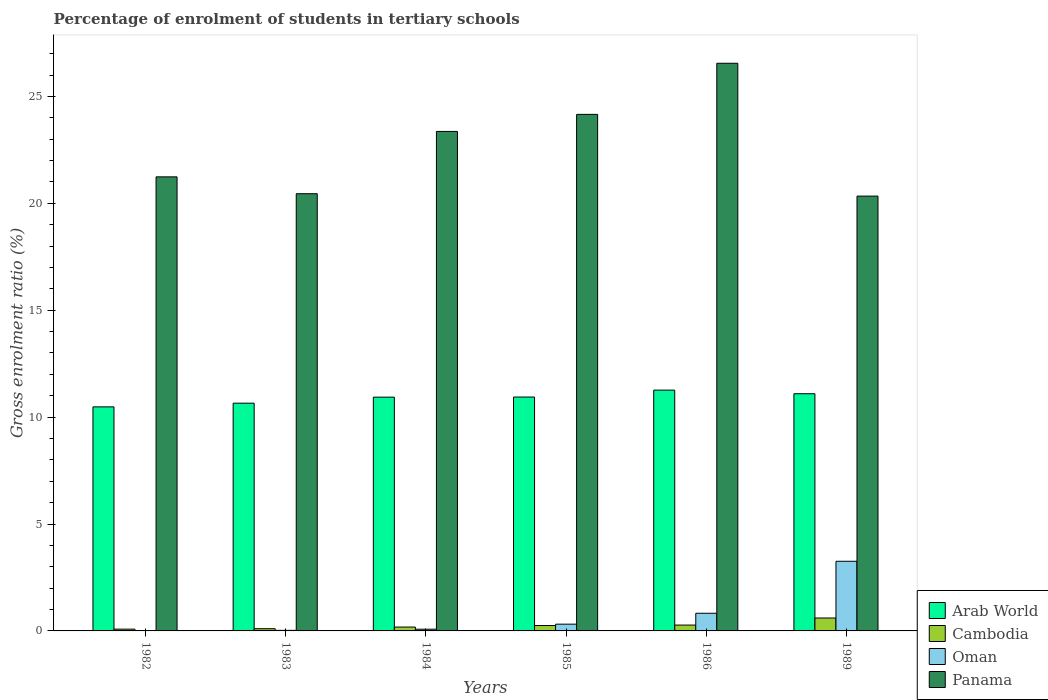How many different coloured bars are there?
Give a very brief answer. 4. Are the number of bars per tick equal to the number of legend labels?
Keep it short and to the point. Yes. Are the number of bars on each tick of the X-axis equal?
Your response must be concise. Yes. How many bars are there on the 2nd tick from the right?
Your response must be concise. 4. What is the label of the 4th group of bars from the left?
Offer a very short reply. 1985. What is the percentage of students enrolled in tertiary schools in Oman in 1986?
Make the answer very short. 0.83. Across all years, what is the maximum percentage of students enrolled in tertiary schools in Oman?
Your answer should be very brief. 3.26. Across all years, what is the minimum percentage of students enrolled in tertiary schools in Panama?
Make the answer very short. 20.34. In which year was the percentage of students enrolled in tertiary schools in Panama minimum?
Give a very brief answer. 1989. What is the total percentage of students enrolled in tertiary schools in Arab World in the graph?
Offer a very short reply. 65.36. What is the difference between the percentage of students enrolled in tertiary schools in Arab World in 1982 and that in 1986?
Offer a terse response. -0.78. What is the difference between the percentage of students enrolled in tertiary schools in Oman in 1983 and the percentage of students enrolled in tertiary schools in Cambodia in 1985?
Give a very brief answer. -0.23. What is the average percentage of students enrolled in tertiary schools in Arab World per year?
Offer a very short reply. 10.89. In the year 1985, what is the difference between the percentage of students enrolled in tertiary schools in Oman and percentage of students enrolled in tertiary schools in Cambodia?
Make the answer very short. 0.06. What is the ratio of the percentage of students enrolled in tertiary schools in Oman in 1983 to that in 1986?
Provide a short and direct response. 0.03. Is the percentage of students enrolled in tertiary schools in Oman in 1984 less than that in 1986?
Provide a succinct answer. Yes. Is the difference between the percentage of students enrolled in tertiary schools in Oman in 1982 and 1985 greater than the difference between the percentage of students enrolled in tertiary schools in Cambodia in 1982 and 1985?
Your response must be concise. No. What is the difference between the highest and the second highest percentage of students enrolled in tertiary schools in Panama?
Your response must be concise. 2.39. What is the difference between the highest and the lowest percentage of students enrolled in tertiary schools in Arab World?
Give a very brief answer. 0.78. Is the sum of the percentage of students enrolled in tertiary schools in Cambodia in 1986 and 1989 greater than the maximum percentage of students enrolled in tertiary schools in Panama across all years?
Your response must be concise. No. Is it the case that in every year, the sum of the percentage of students enrolled in tertiary schools in Cambodia and percentage of students enrolled in tertiary schools in Arab World is greater than the sum of percentage of students enrolled in tertiary schools in Panama and percentage of students enrolled in tertiary schools in Oman?
Keep it short and to the point. Yes. What does the 1st bar from the left in 1986 represents?
Offer a very short reply. Arab World. What does the 4th bar from the right in 1983 represents?
Provide a succinct answer. Arab World. How many bars are there?
Your answer should be very brief. 24. What is the difference between two consecutive major ticks on the Y-axis?
Provide a short and direct response. 5. Does the graph contain grids?
Keep it short and to the point. No. Where does the legend appear in the graph?
Give a very brief answer. Bottom right. What is the title of the graph?
Ensure brevity in your answer.  Percentage of enrolment of students in tertiary schools. What is the label or title of the X-axis?
Keep it short and to the point. Years. What is the Gross enrolment ratio (%) of Arab World in 1982?
Make the answer very short. 10.48. What is the Gross enrolment ratio (%) in Cambodia in 1982?
Give a very brief answer. 0.08. What is the Gross enrolment ratio (%) of Oman in 1982?
Offer a very short reply. 0.01. What is the Gross enrolment ratio (%) of Panama in 1982?
Offer a very short reply. 21.24. What is the Gross enrolment ratio (%) of Arab World in 1983?
Offer a terse response. 10.65. What is the Gross enrolment ratio (%) in Cambodia in 1983?
Provide a succinct answer. 0.1. What is the Gross enrolment ratio (%) in Oman in 1983?
Your response must be concise. 0.03. What is the Gross enrolment ratio (%) of Panama in 1983?
Your answer should be compact. 20.45. What is the Gross enrolment ratio (%) in Arab World in 1984?
Ensure brevity in your answer.  10.93. What is the Gross enrolment ratio (%) of Cambodia in 1984?
Offer a terse response. 0.18. What is the Gross enrolment ratio (%) in Oman in 1984?
Your response must be concise. 0.08. What is the Gross enrolment ratio (%) of Panama in 1984?
Provide a succinct answer. 23.36. What is the Gross enrolment ratio (%) of Arab World in 1985?
Offer a terse response. 10.94. What is the Gross enrolment ratio (%) of Cambodia in 1985?
Provide a succinct answer. 0.25. What is the Gross enrolment ratio (%) in Oman in 1985?
Make the answer very short. 0.32. What is the Gross enrolment ratio (%) in Panama in 1985?
Your response must be concise. 24.16. What is the Gross enrolment ratio (%) in Arab World in 1986?
Offer a terse response. 11.26. What is the Gross enrolment ratio (%) of Cambodia in 1986?
Your answer should be compact. 0.27. What is the Gross enrolment ratio (%) of Oman in 1986?
Offer a terse response. 0.83. What is the Gross enrolment ratio (%) of Panama in 1986?
Your response must be concise. 26.55. What is the Gross enrolment ratio (%) in Arab World in 1989?
Make the answer very short. 11.09. What is the Gross enrolment ratio (%) of Cambodia in 1989?
Keep it short and to the point. 0.6. What is the Gross enrolment ratio (%) of Oman in 1989?
Give a very brief answer. 3.26. What is the Gross enrolment ratio (%) in Panama in 1989?
Make the answer very short. 20.34. Across all years, what is the maximum Gross enrolment ratio (%) of Arab World?
Provide a short and direct response. 11.26. Across all years, what is the maximum Gross enrolment ratio (%) of Cambodia?
Provide a succinct answer. 0.6. Across all years, what is the maximum Gross enrolment ratio (%) of Oman?
Provide a short and direct response. 3.26. Across all years, what is the maximum Gross enrolment ratio (%) in Panama?
Offer a terse response. 26.55. Across all years, what is the minimum Gross enrolment ratio (%) in Arab World?
Provide a short and direct response. 10.48. Across all years, what is the minimum Gross enrolment ratio (%) of Cambodia?
Offer a very short reply. 0.08. Across all years, what is the minimum Gross enrolment ratio (%) in Oman?
Offer a very short reply. 0.01. Across all years, what is the minimum Gross enrolment ratio (%) in Panama?
Make the answer very short. 20.34. What is the total Gross enrolment ratio (%) of Arab World in the graph?
Your answer should be compact. 65.36. What is the total Gross enrolment ratio (%) in Cambodia in the graph?
Keep it short and to the point. 1.5. What is the total Gross enrolment ratio (%) of Oman in the graph?
Offer a very short reply. 4.52. What is the total Gross enrolment ratio (%) of Panama in the graph?
Your response must be concise. 136.09. What is the difference between the Gross enrolment ratio (%) in Arab World in 1982 and that in 1983?
Make the answer very short. -0.17. What is the difference between the Gross enrolment ratio (%) in Cambodia in 1982 and that in 1983?
Provide a succinct answer. -0.02. What is the difference between the Gross enrolment ratio (%) of Oman in 1982 and that in 1983?
Make the answer very short. -0.01. What is the difference between the Gross enrolment ratio (%) of Panama in 1982 and that in 1983?
Keep it short and to the point. 0.79. What is the difference between the Gross enrolment ratio (%) of Arab World in 1982 and that in 1984?
Give a very brief answer. -0.45. What is the difference between the Gross enrolment ratio (%) of Cambodia in 1982 and that in 1984?
Offer a very short reply. -0.1. What is the difference between the Gross enrolment ratio (%) of Oman in 1982 and that in 1984?
Your answer should be very brief. -0.07. What is the difference between the Gross enrolment ratio (%) of Panama in 1982 and that in 1984?
Offer a very short reply. -2.12. What is the difference between the Gross enrolment ratio (%) of Arab World in 1982 and that in 1985?
Keep it short and to the point. -0.46. What is the difference between the Gross enrolment ratio (%) of Cambodia in 1982 and that in 1985?
Your answer should be compact. -0.17. What is the difference between the Gross enrolment ratio (%) in Oman in 1982 and that in 1985?
Provide a short and direct response. -0.3. What is the difference between the Gross enrolment ratio (%) in Panama in 1982 and that in 1985?
Make the answer very short. -2.92. What is the difference between the Gross enrolment ratio (%) of Arab World in 1982 and that in 1986?
Make the answer very short. -0.78. What is the difference between the Gross enrolment ratio (%) in Cambodia in 1982 and that in 1986?
Give a very brief answer. -0.19. What is the difference between the Gross enrolment ratio (%) of Oman in 1982 and that in 1986?
Make the answer very short. -0.81. What is the difference between the Gross enrolment ratio (%) of Panama in 1982 and that in 1986?
Make the answer very short. -5.31. What is the difference between the Gross enrolment ratio (%) in Arab World in 1982 and that in 1989?
Keep it short and to the point. -0.61. What is the difference between the Gross enrolment ratio (%) of Cambodia in 1982 and that in 1989?
Offer a terse response. -0.52. What is the difference between the Gross enrolment ratio (%) of Oman in 1982 and that in 1989?
Your answer should be compact. -3.24. What is the difference between the Gross enrolment ratio (%) in Panama in 1982 and that in 1989?
Your answer should be compact. 0.9. What is the difference between the Gross enrolment ratio (%) of Arab World in 1983 and that in 1984?
Your answer should be very brief. -0.28. What is the difference between the Gross enrolment ratio (%) in Cambodia in 1983 and that in 1984?
Your response must be concise. -0.08. What is the difference between the Gross enrolment ratio (%) of Oman in 1983 and that in 1984?
Give a very brief answer. -0.05. What is the difference between the Gross enrolment ratio (%) in Panama in 1983 and that in 1984?
Your answer should be compact. -2.91. What is the difference between the Gross enrolment ratio (%) in Arab World in 1983 and that in 1985?
Make the answer very short. -0.29. What is the difference between the Gross enrolment ratio (%) in Cambodia in 1983 and that in 1985?
Offer a very short reply. -0.15. What is the difference between the Gross enrolment ratio (%) of Oman in 1983 and that in 1985?
Offer a very short reply. -0.29. What is the difference between the Gross enrolment ratio (%) of Panama in 1983 and that in 1985?
Provide a succinct answer. -3.71. What is the difference between the Gross enrolment ratio (%) of Arab World in 1983 and that in 1986?
Provide a short and direct response. -0.61. What is the difference between the Gross enrolment ratio (%) in Cambodia in 1983 and that in 1986?
Your response must be concise. -0.17. What is the difference between the Gross enrolment ratio (%) in Oman in 1983 and that in 1986?
Ensure brevity in your answer.  -0.8. What is the difference between the Gross enrolment ratio (%) of Panama in 1983 and that in 1986?
Offer a terse response. -6.1. What is the difference between the Gross enrolment ratio (%) of Arab World in 1983 and that in 1989?
Keep it short and to the point. -0.44. What is the difference between the Gross enrolment ratio (%) in Cambodia in 1983 and that in 1989?
Keep it short and to the point. -0.5. What is the difference between the Gross enrolment ratio (%) in Oman in 1983 and that in 1989?
Your answer should be compact. -3.23. What is the difference between the Gross enrolment ratio (%) of Panama in 1983 and that in 1989?
Make the answer very short. 0.11. What is the difference between the Gross enrolment ratio (%) in Arab World in 1984 and that in 1985?
Make the answer very short. -0. What is the difference between the Gross enrolment ratio (%) in Cambodia in 1984 and that in 1985?
Your answer should be very brief. -0.07. What is the difference between the Gross enrolment ratio (%) in Oman in 1984 and that in 1985?
Make the answer very short. -0.24. What is the difference between the Gross enrolment ratio (%) of Panama in 1984 and that in 1985?
Provide a short and direct response. -0.8. What is the difference between the Gross enrolment ratio (%) in Arab World in 1984 and that in 1986?
Ensure brevity in your answer.  -0.33. What is the difference between the Gross enrolment ratio (%) of Cambodia in 1984 and that in 1986?
Provide a short and direct response. -0.09. What is the difference between the Gross enrolment ratio (%) in Oman in 1984 and that in 1986?
Give a very brief answer. -0.75. What is the difference between the Gross enrolment ratio (%) in Panama in 1984 and that in 1986?
Offer a terse response. -3.19. What is the difference between the Gross enrolment ratio (%) in Arab World in 1984 and that in 1989?
Your answer should be compact. -0.16. What is the difference between the Gross enrolment ratio (%) of Cambodia in 1984 and that in 1989?
Your answer should be compact. -0.42. What is the difference between the Gross enrolment ratio (%) in Oman in 1984 and that in 1989?
Your answer should be compact. -3.18. What is the difference between the Gross enrolment ratio (%) of Panama in 1984 and that in 1989?
Give a very brief answer. 3.03. What is the difference between the Gross enrolment ratio (%) in Arab World in 1985 and that in 1986?
Your answer should be compact. -0.32. What is the difference between the Gross enrolment ratio (%) in Cambodia in 1985 and that in 1986?
Provide a short and direct response. -0.02. What is the difference between the Gross enrolment ratio (%) in Oman in 1985 and that in 1986?
Keep it short and to the point. -0.51. What is the difference between the Gross enrolment ratio (%) of Panama in 1985 and that in 1986?
Give a very brief answer. -2.39. What is the difference between the Gross enrolment ratio (%) in Arab World in 1985 and that in 1989?
Make the answer very short. -0.16. What is the difference between the Gross enrolment ratio (%) of Cambodia in 1985 and that in 1989?
Keep it short and to the point. -0.35. What is the difference between the Gross enrolment ratio (%) of Oman in 1985 and that in 1989?
Offer a terse response. -2.94. What is the difference between the Gross enrolment ratio (%) of Panama in 1985 and that in 1989?
Offer a terse response. 3.82. What is the difference between the Gross enrolment ratio (%) in Arab World in 1986 and that in 1989?
Make the answer very short. 0.17. What is the difference between the Gross enrolment ratio (%) in Cambodia in 1986 and that in 1989?
Give a very brief answer. -0.33. What is the difference between the Gross enrolment ratio (%) of Oman in 1986 and that in 1989?
Give a very brief answer. -2.43. What is the difference between the Gross enrolment ratio (%) of Panama in 1986 and that in 1989?
Your response must be concise. 6.21. What is the difference between the Gross enrolment ratio (%) of Arab World in 1982 and the Gross enrolment ratio (%) of Cambodia in 1983?
Keep it short and to the point. 10.38. What is the difference between the Gross enrolment ratio (%) of Arab World in 1982 and the Gross enrolment ratio (%) of Oman in 1983?
Provide a short and direct response. 10.45. What is the difference between the Gross enrolment ratio (%) in Arab World in 1982 and the Gross enrolment ratio (%) in Panama in 1983?
Offer a very short reply. -9.97. What is the difference between the Gross enrolment ratio (%) of Cambodia in 1982 and the Gross enrolment ratio (%) of Oman in 1983?
Give a very brief answer. 0.06. What is the difference between the Gross enrolment ratio (%) of Cambodia in 1982 and the Gross enrolment ratio (%) of Panama in 1983?
Offer a terse response. -20.37. What is the difference between the Gross enrolment ratio (%) in Oman in 1982 and the Gross enrolment ratio (%) in Panama in 1983?
Offer a terse response. -20.44. What is the difference between the Gross enrolment ratio (%) in Arab World in 1982 and the Gross enrolment ratio (%) in Cambodia in 1984?
Give a very brief answer. 10.3. What is the difference between the Gross enrolment ratio (%) in Arab World in 1982 and the Gross enrolment ratio (%) in Oman in 1984?
Provide a short and direct response. 10.4. What is the difference between the Gross enrolment ratio (%) of Arab World in 1982 and the Gross enrolment ratio (%) of Panama in 1984?
Your answer should be very brief. -12.88. What is the difference between the Gross enrolment ratio (%) in Cambodia in 1982 and the Gross enrolment ratio (%) in Oman in 1984?
Your answer should be compact. 0. What is the difference between the Gross enrolment ratio (%) of Cambodia in 1982 and the Gross enrolment ratio (%) of Panama in 1984?
Offer a very short reply. -23.28. What is the difference between the Gross enrolment ratio (%) of Oman in 1982 and the Gross enrolment ratio (%) of Panama in 1984?
Offer a very short reply. -23.35. What is the difference between the Gross enrolment ratio (%) in Arab World in 1982 and the Gross enrolment ratio (%) in Cambodia in 1985?
Offer a very short reply. 10.23. What is the difference between the Gross enrolment ratio (%) of Arab World in 1982 and the Gross enrolment ratio (%) of Oman in 1985?
Your answer should be very brief. 10.16. What is the difference between the Gross enrolment ratio (%) in Arab World in 1982 and the Gross enrolment ratio (%) in Panama in 1985?
Offer a terse response. -13.68. What is the difference between the Gross enrolment ratio (%) in Cambodia in 1982 and the Gross enrolment ratio (%) in Oman in 1985?
Provide a succinct answer. -0.23. What is the difference between the Gross enrolment ratio (%) of Cambodia in 1982 and the Gross enrolment ratio (%) of Panama in 1985?
Give a very brief answer. -24.08. What is the difference between the Gross enrolment ratio (%) in Oman in 1982 and the Gross enrolment ratio (%) in Panama in 1985?
Keep it short and to the point. -24.15. What is the difference between the Gross enrolment ratio (%) in Arab World in 1982 and the Gross enrolment ratio (%) in Cambodia in 1986?
Offer a terse response. 10.21. What is the difference between the Gross enrolment ratio (%) of Arab World in 1982 and the Gross enrolment ratio (%) of Oman in 1986?
Ensure brevity in your answer.  9.65. What is the difference between the Gross enrolment ratio (%) of Arab World in 1982 and the Gross enrolment ratio (%) of Panama in 1986?
Offer a very short reply. -16.07. What is the difference between the Gross enrolment ratio (%) of Cambodia in 1982 and the Gross enrolment ratio (%) of Oman in 1986?
Provide a succinct answer. -0.74. What is the difference between the Gross enrolment ratio (%) in Cambodia in 1982 and the Gross enrolment ratio (%) in Panama in 1986?
Ensure brevity in your answer.  -26.47. What is the difference between the Gross enrolment ratio (%) in Oman in 1982 and the Gross enrolment ratio (%) in Panama in 1986?
Provide a short and direct response. -26.54. What is the difference between the Gross enrolment ratio (%) in Arab World in 1982 and the Gross enrolment ratio (%) in Cambodia in 1989?
Provide a short and direct response. 9.87. What is the difference between the Gross enrolment ratio (%) of Arab World in 1982 and the Gross enrolment ratio (%) of Oman in 1989?
Give a very brief answer. 7.22. What is the difference between the Gross enrolment ratio (%) of Arab World in 1982 and the Gross enrolment ratio (%) of Panama in 1989?
Your answer should be very brief. -9.86. What is the difference between the Gross enrolment ratio (%) in Cambodia in 1982 and the Gross enrolment ratio (%) in Oman in 1989?
Ensure brevity in your answer.  -3.17. What is the difference between the Gross enrolment ratio (%) of Cambodia in 1982 and the Gross enrolment ratio (%) of Panama in 1989?
Offer a very short reply. -20.25. What is the difference between the Gross enrolment ratio (%) of Oman in 1982 and the Gross enrolment ratio (%) of Panama in 1989?
Your response must be concise. -20.32. What is the difference between the Gross enrolment ratio (%) of Arab World in 1983 and the Gross enrolment ratio (%) of Cambodia in 1984?
Keep it short and to the point. 10.47. What is the difference between the Gross enrolment ratio (%) of Arab World in 1983 and the Gross enrolment ratio (%) of Oman in 1984?
Keep it short and to the point. 10.57. What is the difference between the Gross enrolment ratio (%) of Arab World in 1983 and the Gross enrolment ratio (%) of Panama in 1984?
Your answer should be very brief. -12.71. What is the difference between the Gross enrolment ratio (%) of Cambodia in 1983 and the Gross enrolment ratio (%) of Oman in 1984?
Provide a short and direct response. 0.02. What is the difference between the Gross enrolment ratio (%) of Cambodia in 1983 and the Gross enrolment ratio (%) of Panama in 1984?
Provide a short and direct response. -23.26. What is the difference between the Gross enrolment ratio (%) of Oman in 1983 and the Gross enrolment ratio (%) of Panama in 1984?
Provide a short and direct response. -23.34. What is the difference between the Gross enrolment ratio (%) in Arab World in 1983 and the Gross enrolment ratio (%) in Cambodia in 1985?
Provide a short and direct response. 10.4. What is the difference between the Gross enrolment ratio (%) of Arab World in 1983 and the Gross enrolment ratio (%) of Oman in 1985?
Provide a short and direct response. 10.34. What is the difference between the Gross enrolment ratio (%) of Arab World in 1983 and the Gross enrolment ratio (%) of Panama in 1985?
Your answer should be very brief. -13.51. What is the difference between the Gross enrolment ratio (%) of Cambodia in 1983 and the Gross enrolment ratio (%) of Oman in 1985?
Make the answer very short. -0.21. What is the difference between the Gross enrolment ratio (%) of Cambodia in 1983 and the Gross enrolment ratio (%) of Panama in 1985?
Offer a very short reply. -24.05. What is the difference between the Gross enrolment ratio (%) in Oman in 1983 and the Gross enrolment ratio (%) in Panama in 1985?
Provide a short and direct response. -24.13. What is the difference between the Gross enrolment ratio (%) in Arab World in 1983 and the Gross enrolment ratio (%) in Cambodia in 1986?
Offer a very short reply. 10.38. What is the difference between the Gross enrolment ratio (%) in Arab World in 1983 and the Gross enrolment ratio (%) in Oman in 1986?
Your answer should be very brief. 9.83. What is the difference between the Gross enrolment ratio (%) of Arab World in 1983 and the Gross enrolment ratio (%) of Panama in 1986?
Make the answer very short. -15.9. What is the difference between the Gross enrolment ratio (%) in Cambodia in 1983 and the Gross enrolment ratio (%) in Oman in 1986?
Give a very brief answer. -0.72. What is the difference between the Gross enrolment ratio (%) of Cambodia in 1983 and the Gross enrolment ratio (%) of Panama in 1986?
Make the answer very short. -26.45. What is the difference between the Gross enrolment ratio (%) in Oman in 1983 and the Gross enrolment ratio (%) in Panama in 1986?
Keep it short and to the point. -26.52. What is the difference between the Gross enrolment ratio (%) in Arab World in 1983 and the Gross enrolment ratio (%) in Cambodia in 1989?
Provide a short and direct response. 10.05. What is the difference between the Gross enrolment ratio (%) in Arab World in 1983 and the Gross enrolment ratio (%) in Oman in 1989?
Ensure brevity in your answer.  7.39. What is the difference between the Gross enrolment ratio (%) in Arab World in 1983 and the Gross enrolment ratio (%) in Panama in 1989?
Make the answer very short. -9.68. What is the difference between the Gross enrolment ratio (%) of Cambodia in 1983 and the Gross enrolment ratio (%) of Oman in 1989?
Keep it short and to the point. -3.15. What is the difference between the Gross enrolment ratio (%) in Cambodia in 1983 and the Gross enrolment ratio (%) in Panama in 1989?
Ensure brevity in your answer.  -20.23. What is the difference between the Gross enrolment ratio (%) of Oman in 1983 and the Gross enrolment ratio (%) of Panama in 1989?
Provide a succinct answer. -20.31. What is the difference between the Gross enrolment ratio (%) in Arab World in 1984 and the Gross enrolment ratio (%) in Cambodia in 1985?
Offer a very short reply. 10.68. What is the difference between the Gross enrolment ratio (%) of Arab World in 1984 and the Gross enrolment ratio (%) of Oman in 1985?
Your response must be concise. 10.62. What is the difference between the Gross enrolment ratio (%) of Arab World in 1984 and the Gross enrolment ratio (%) of Panama in 1985?
Your answer should be very brief. -13.22. What is the difference between the Gross enrolment ratio (%) of Cambodia in 1984 and the Gross enrolment ratio (%) of Oman in 1985?
Offer a very short reply. -0.14. What is the difference between the Gross enrolment ratio (%) of Cambodia in 1984 and the Gross enrolment ratio (%) of Panama in 1985?
Provide a short and direct response. -23.98. What is the difference between the Gross enrolment ratio (%) of Oman in 1984 and the Gross enrolment ratio (%) of Panama in 1985?
Give a very brief answer. -24.08. What is the difference between the Gross enrolment ratio (%) in Arab World in 1984 and the Gross enrolment ratio (%) in Cambodia in 1986?
Provide a succinct answer. 10.66. What is the difference between the Gross enrolment ratio (%) of Arab World in 1984 and the Gross enrolment ratio (%) of Oman in 1986?
Ensure brevity in your answer.  10.11. What is the difference between the Gross enrolment ratio (%) in Arab World in 1984 and the Gross enrolment ratio (%) in Panama in 1986?
Give a very brief answer. -15.62. What is the difference between the Gross enrolment ratio (%) of Cambodia in 1984 and the Gross enrolment ratio (%) of Oman in 1986?
Make the answer very short. -0.65. What is the difference between the Gross enrolment ratio (%) in Cambodia in 1984 and the Gross enrolment ratio (%) in Panama in 1986?
Offer a terse response. -26.37. What is the difference between the Gross enrolment ratio (%) in Oman in 1984 and the Gross enrolment ratio (%) in Panama in 1986?
Provide a short and direct response. -26.47. What is the difference between the Gross enrolment ratio (%) of Arab World in 1984 and the Gross enrolment ratio (%) of Cambodia in 1989?
Ensure brevity in your answer.  10.33. What is the difference between the Gross enrolment ratio (%) of Arab World in 1984 and the Gross enrolment ratio (%) of Oman in 1989?
Your answer should be very brief. 7.68. What is the difference between the Gross enrolment ratio (%) of Arab World in 1984 and the Gross enrolment ratio (%) of Panama in 1989?
Provide a succinct answer. -9.4. What is the difference between the Gross enrolment ratio (%) of Cambodia in 1984 and the Gross enrolment ratio (%) of Oman in 1989?
Your answer should be compact. -3.08. What is the difference between the Gross enrolment ratio (%) in Cambodia in 1984 and the Gross enrolment ratio (%) in Panama in 1989?
Offer a terse response. -20.16. What is the difference between the Gross enrolment ratio (%) in Oman in 1984 and the Gross enrolment ratio (%) in Panama in 1989?
Make the answer very short. -20.26. What is the difference between the Gross enrolment ratio (%) in Arab World in 1985 and the Gross enrolment ratio (%) in Cambodia in 1986?
Provide a short and direct response. 10.67. What is the difference between the Gross enrolment ratio (%) of Arab World in 1985 and the Gross enrolment ratio (%) of Oman in 1986?
Your response must be concise. 10.11. What is the difference between the Gross enrolment ratio (%) of Arab World in 1985 and the Gross enrolment ratio (%) of Panama in 1986?
Your response must be concise. -15.61. What is the difference between the Gross enrolment ratio (%) of Cambodia in 1985 and the Gross enrolment ratio (%) of Oman in 1986?
Provide a succinct answer. -0.57. What is the difference between the Gross enrolment ratio (%) of Cambodia in 1985 and the Gross enrolment ratio (%) of Panama in 1986?
Ensure brevity in your answer.  -26.3. What is the difference between the Gross enrolment ratio (%) of Oman in 1985 and the Gross enrolment ratio (%) of Panama in 1986?
Offer a terse response. -26.23. What is the difference between the Gross enrolment ratio (%) in Arab World in 1985 and the Gross enrolment ratio (%) in Cambodia in 1989?
Provide a short and direct response. 10.33. What is the difference between the Gross enrolment ratio (%) of Arab World in 1985 and the Gross enrolment ratio (%) of Oman in 1989?
Your answer should be compact. 7.68. What is the difference between the Gross enrolment ratio (%) in Arab World in 1985 and the Gross enrolment ratio (%) in Panama in 1989?
Give a very brief answer. -9.4. What is the difference between the Gross enrolment ratio (%) in Cambodia in 1985 and the Gross enrolment ratio (%) in Oman in 1989?
Provide a succinct answer. -3.01. What is the difference between the Gross enrolment ratio (%) of Cambodia in 1985 and the Gross enrolment ratio (%) of Panama in 1989?
Give a very brief answer. -20.08. What is the difference between the Gross enrolment ratio (%) of Oman in 1985 and the Gross enrolment ratio (%) of Panama in 1989?
Make the answer very short. -20.02. What is the difference between the Gross enrolment ratio (%) in Arab World in 1986 and the Gross enrolment ratio (%) in Cambodia in 1989?
Keep it short and to the point. 10.66. What is the difference between the Gross enrolment ratio (%) in Arab World in 1986 and the Gross enrolment ratio (%) in Oman in 1989?
Provide a short and direct response. 8. What is the difference between the Gross enrolment ratio (%) in Arab World in 1986 and the Gross enrolment ratio (%) in Panama in 1989?
Provide a succinct answer. -9.07. What is the difference between the Gross enrolment ratio (%) of Cambodia in 1986 and the Gross enrolment ratio (%) of Oman in 1989?
Your answer should be very brief. -2.98. What is the difference between the Gross enrolment ratio (%) in Cambodia in 1986 and the Gross enrolment ratio (%) in Panama in 1989?
Make the answer very short. -20.06. What is the difference between the Gross enrolment ratio (%) of Oman in 1986 and the Gross enrolment ratio (%) of Panama in 1989?
Provide a succinct answer. -19.51. What is the average Gross enrolment ratio (%) of Arab World per year?
Keep it short and to the point. 10.89. What is the average Gross enrolment ratio (%) of Cambodia per year?
Make the answer very short. 0.25. What is the average Gross enrolment ratio (%) in Oman per year?
Ensure brevity in your answer.  0.75. What is the average Gross enrolment ratio (%) of Panama per year?
Your answer should be very brief. 22.68. In the year 1982, what is the difference between the Gross enrolment ratio (%) in Arab World and Gross enrolment ratio (%) in Cambodia?
Offer a very short reply. 10.4. In the year 1982, what is the difference between the Gross enrolment ratio (%) of Arab World and Gross enrolment ratio (%) of Oman?
Keep it short and to the point. 10.47. In the year 1982, what is the difference between the Gross enrolment ratio (%) in Arab World and Gross enrolment ratio (%) in Panama?
Keep it short and to the point. -10.76. In the year 1982, what is the difference between the Gross enrolment ratio (%) of Cambodia and Gross enrolment ratio (%) of Oman?
Ensure brevity in your answer.  0.07. In the year 1982, what is the difference between the Gross enrolment ratio (%) in Cambodia and Gross enrolment ratio (%) in Panama?
Make the answer very short. -21.15. In the year 1982, what is the difference between the Gross enrolment ratio (%) in Oman and Gross enrolment ratio (%) in Panama?
Your answer should be very brief. -21.22. In the year 1983, what is the difference between the Gross enrolment ratio (%) of Arab World and Gross enrolment ratio (%) of Cambodia?
Make the answer very short. 10.55. In the year 1983, what is the difference between the Gross enrolment ratio (%) of Arab World and Gross enrolment ratio (%) of Oman?
Give a very brief answer. 10.63. In the year 1983, what is the difference between the Gross enrolment ratio (%) in Arab World and Gross enrolment ratio (%) in Panama?
Offer a very short reply. -9.8. In the year 1983, what is the difference between the Gross enrolment ratio (%) of Cambodia and Gross enrolment ratio (%) of Oman?
Ensure brevity in your answer.  0.08. In the year 1983, what is the difference between the Gross enrolment ratio (%) of Cambodia and Gross enrolment ratio (%) of Panama?
Keep it short and to the point. -20.34. In the year 1983, what is the difference between the Gross enrolment ratio (%) in Oman and Gross enrolment ratio (%) in Panama?
Your answer should be very brief. -20.42. In the year 1984, what is the difference between the Gross enrolment ratio (%) of Arab World and Gross enrolment ratio (%) of Cambodia?
Offer a terse response. 10.75. In the year 1984, what is the difference between the Gross enrolment ratio (%) of Arab World and Gross enrolment ratio (%) of Oman?
Keep it short and to the point. 10.85. In the year 1984, what is the difference between the Gross enrolment ratio (%) of Arab World and Gross enrolment ratio (%) of Panama?
Provide a short and direct response. -12.43. In the year 1984, what is the difference between the Gross enrolment ratio (%) in Cambodia and Gross enrolment ratio (%) in Panama?
Offer a terse response. -23.18. In the year 1984, what is the difference between the Gross enrolment ratio (%) of Oman and Gross enrolment ratio (%) of Panama?
Give a very brief answer. -23.28. In the year 1985, what is the difference between the Gross enrolment ratio (%) of Arab World and Gross enrolment ratio (%) of Cambodia?
Provide a succinct answer. 10.69. In the year 1985, what is the difference between the Gross enrolment ratio (%) in Arab World and Gross enrolment ratio (%) in Oman?
Offer a terse response. 10.62. In the year 1985, what is the difference between the Gross enrolment ratio (%) of Arab World and Gross enrolment ratio (%) of Panama?
Your answer should be very brief. -13.22. In the year 1985, what is the difference between the Gross enrolment ratio (%) in Cambodia and Gross enrolment ratio (%) in Oman?
Offer a terse response. -0.06. In the year 1985, what is the difference between the Gross enrolment ratio (%) in Cambodia and Gross enrolment ratio (%) in Panama?
Your answer should be compact. -23.91. In the year 1985, what is the difference between the Gross enrolment ratio (%) in Oman and Gross enrolment ratio (%) in Panama?
Keep it short and to the point. -23.84. In the year 1986, what is the difference between the Gross enrolment ratio (%) of Arab World and Gross enrolment ratio (%) of Cambodia?
Your response must be concise. 10.99. In the year 1986, what is the difference between the Gross enrolment ratio (%) in Arab World and Gross enrolment ratio (%) in Oman?
Keep it short and to the point. 10.44. In the year 1986, what is the difference between the Gross enrolment ratio (%) in Arab World and Gross enrolment ratio (%) in Panama?
Keep it short and to the point. -15.29. In the year 1986, what is the difference between the Gross enrolment ratio (%) in Cambodia and Gross enrolment ratio (%) in Oman?
Offer a terse response. -0.55. In the year 1986, what is the difference between the Gross enrolment ratio (%) of Cambodia and Gross enrolment ratio (%) of Panama?
Offer a very short reply. -26.28. In the year 1986, what is the difference between the Gross enrolment ratio (%) in Oman and Gross enrolment ratio (%) in Panama?
Keep it short and to the point. -25.72. In the year 1989, what is the difference between the Gross enrolment ratio (%) of Arab World and Gross enrolment ratio (%) of Cambodia?
Your response must be concise. 10.49. In the year 1989, what is the difference between the Gross enrolment ratio (%) in Arab World and Gross enrolment ratio (%) in Oman?
Provide a short and direct response. 7.84. In the year 1989, what is the difference between the Gross enrolment ratio (%) of Arab World and Gross enrolment ratio (%) of Panama?
Your answer should be compact. -9.24. In the year 1989, what is the difference between the Gross enrolment ratio (%) of Cambodia and Gross enrolment ratio (%) of Oman?
Provide a short and direct response. -2.65. In the year 1989, what is the difference between the Gross enrolment ratio (%) of Cambodia and Gross enrolment ratio (%) of Panama?
Provide a succinct answer. -19.73. In the year 1989, what is the difference between the Gross enrolment ratio (%) in Oman and Gross enrolment ratio (%) in Panama?
Your answer should be compact. -17.08. What is the ratio of the Gross enrolment ratio (%) of Arab World in 1982 to that in 1983?
Give a very brief answer. 0.98. What is the ratio of the Gross enrolment ratio (%) of Cambodia in 1982 to that in 1983?
Make the answer very short. 0.8. What is the ratio of the Gross enrolment ratio (%) in Oman in 1982 to that in 1983?
Offer a very short reply. 0.5. What is the ratio of the Gross enrolment ratio (%) of Panama in 1982 to that in 1983?
Your answer should be compact. 1.04. What is the ratio of the Gross enrolment ratio (%) of Arab World in 1982 to that in 1984?
Provide a succinct answer. 0.96. What is the ratio of the Gross enrolment ratio (%) in Cambodia in 1982 to that in 1984?
Offer a very short reply. 0.46. What is the ratio of the Gross enrolment ratio (%) of Oman in 1982 to that in 1984?
Offer a terse response. 0.17. What is the ratio of the Gross enrolment ratio (%) of Panama in 1982 to that in 1984?
Give a very brief answer. 0.91. What is the ratio of the Gross enrolment ratio (%) in Arab World in 1982 to that in 1985?
Your answer should be compact. 0.96. What is the ratio of the Gross enrolment ratio (%) in Cambodia in 1982 to that in 1985?
Your answer should be very brief. 0.33. What is the ratio of the Gross enrolment ratio (%) of Oman in 1982 to that in 1985?
Your response must be concise. 0.04. What is the ratio of the Gross enrolment ratio (%) of Panama in 1982 to that in 1985?
Provide a succinct answer. 0.88. What is the ratio of the Gross enrolment ratio (%) of Arab World in 1982 to that in 1986?
Provide a short and direct response. 0.93. What is the ratio of the Gross enrolment ratio (%) of Cambodia in 1982 to that in 1986?
Provide a short and direct response. 0.3. What is the ratio of the Gross enrolment ratio (%) in Oman in 1982 to that in 1986?
Give a very brief answer. 0.02. What is the ratio of the Gross enrolment ratio (%) in Panama in 1982 to that in 1986?
Keep it short and to the point. 0.8. What is the ratio of the Gross enrolment ratio (%) in Arab World in 1982 to that in 1989?
Provide a short and direct response. 0.94. What is the ratio of the Gross enrolment ratio (%) of Cambodia in 1982 to that in 1989?
Ensure brevity in your answer.  0.14. What is the ratio of the Gross enrolment ratio (%) in Oman in 1982 to that in 1989?
Provide a succinct answer. 0. What is the ratio of the Gross enrolment ratio (%) in Panama in 1982 to that in 1989?
Offer a terse response. 1.04. What is the ratio of the Gross enrolment ratio (%) of Arab World in 1983 to that in 1984?
Provide a short and direct response. 0.97. What is the ratio of the Gross enrolment ratio (%) in Cambodia in 1983 to that in 1984?
Make the answer very short. 0.58. What is the ratio of the Gross enrolment ratio (%) of Oman in 1983 to that in 1984?
Your response must be concise. 0.33. What is the ratio of the Gross enrolment ratio (%) of Panama in 1983 to that in 1984?
Provide a short and direct response. 0.88. What is the ratio of the Gross enrolment ratio (%) in Arab World in 1983 to that in 1985?
Ensure brevity in your answer.  0.97. What is the ratio of the Gross enrolment ratio (%) in Cambodia in 1983 to that in 1985?
Give a very brief answer. 0.41. What is the ratio of the Gross enrolment ratio (%) of Oman in 1983 to that in 1985?
Make the answer very short. 0.08. What is the ratio of the Gross enrolment ratio (%) in Panama in 1983 to that in 1985?
Ensure brevity in your answer.  0.85. What is the ratio of the Gross enrolment ratio (%) in Arab World in 1983 to that in 1986?
Offer a terse response. 0.95. What is the ratio of the Gross enrolment ratio (%) of Cambodia in 1983 to that in 1986?
Provide a succinct answer. 0.38. What is the ratio of the Gross enrolment ratio (%) of Oman in 1983 to that in 1986?
Keep it short and to the point. 0.03. What is the ratio of the Gross enrolment ratio (%) of Panama in 1983 to that in 1986?
Provide a short and direct response. 0.77. What is the ratio of the Gross enrolment ratio (%) of Arab World in 1983 to that in 1989?
Make the answer very short. 0.96. What is the ratio of the Gross enrolment ratio (%) of Cambodia in 1983 to that in 1989?
Ensure brevity in your answer.  0.17. What is the ratio of the Gross enrolment ratio (%) in Oman in 1983 to that in 1989?
Your answer should be very brief. 0.01. What is the ratio of the Gross enrolment ratio (%) in Arab World in 1984 to that in 1985?
Your response must be concise. 1. What is the ratio of the Gross enrolment ratio (%) in Cambodia in 1984 to that in 1985?
Give a very brief answer. 0.72. What is the ratio of the Gross enrolment ratio (%) in Oman in 1984 to that in 1985?
Your answer should be very brief. 0.25. What is the ratio of the Gross enrolment ratio (%) of Arab World in 1984 to that in 1986?
Give a very brief answer. 0.97. What is the ratio of the Gross enrolment ratio (%) in Cambodia in 1984 to that in 1986?
Your response must be concise. 0.66. What is the ratio of the Gross enrolment ratio (%) in Oman in 1984 to that in 1986?
Offer a very short reply. 0.1. What is the ratio of the Gross enrolment ratio (%) in Panama in 1984 to that in 1986?
Provide a succinct answer. 0.88. What is the ratio of the Gross enrolment ratio (%) of Arab World in 1984 to that in 1989?
Keep it short and to the point. 0.99. What is the ratio of the Gross enrolment ratio (%) of Cambodia in 1984 to that in 1989?
Provide a succinct answer. 0.3. What is the ratio of the Gross enrolment ratio (%) of Oman in 1984 to that in 1989?
Keep it short and to the point. 0.02. What is the ratio of the Gross enrolment ratio (%) in Panama in 1984 to that in 1989?
Offer a very short reply. 1.15. What is the ratio of the Gross enrolment ratio (%) of Arab World in 1985 to that in 1986?
Offer a very short reply. 0.97. What is the ratio of the Gross enrolment ratio (%) in Cambodia in 1985 to that in 1986?
Keep it short and to the point. 0.92. What is the ratio of the Gross enrolment ratio (%) in Oman in 1985 to that in 1986?
Offer a very short reply. 0.38. What is the ratio of the Gross enrolment ratio (%) in Panama in 1985 to that in 1986?
Offer a terse response. 0.91. What is the ratio of the Gross enrolment ratio (%) of Arab World in 1985 to that in 1989?
Offer a terse response. 0.99. What is the ratio of the Gross enrolment ratio (%) of Cambodia in 1985 to that in 1989?
Offer a very short reply. 0.42. What is the ratio of the Gross enrolment ratio (%) of Oman in 1985 to that in 1989?
Ensure brevity in your answer.  0.1. What is the ratio of the Gross enrolment ratio (%) in Panama in 1985 to that in 1989?
Your response must be concise. 1.19. What is the ratio of the Gross enrolment ratio (%) in Arab World in 1986 to that in 1989?
Provide a short and direct response. 1.02. What is the ratio of the Gross enrolment ratio (%) in Cambodia in 1986 to that in 1989?
Ensure brevity in your answer.  0.45. What is the ratio of the Gross enrolment ratio (%) of Oman in 1986 to that in 1989?
Offer a terse response. 0.25. What is the ratio of the Gross enrolment ratio (%) of Panama in 1986 to that in 1989?
Ensure brevity in your answer.  1.31. What is the difference between the highest and the second highest Gross enrolment ratio (%) of Arab World?
Keep it short and to the point. 0.17. What is the difference between the highest and the second highest Gross enrolment ratio (%) of Cambodia?
Give a very brief answer. 0.33. What is the difference between the highest and the second highest Gross enrolment ratio (%) in Oman?
Your answer should be compact. 2.43. What is the difference between the highest and the second highest Gross enrolment ratio (%) in Panama?
Provide a succinct answer. 2.39. What is the difference between the highest and the lowest Gross enrolment ratio (%) of Arab World?
Give a very brief answer. 0.78. What is the difference between the highest and the lowest Gross enrolment ratio (%) in Cambodia?
Give a very brief answer. 0.52. What is the difference between the highest and the lowest Gross enrolment ratio (%) of Oman?
Your answer should be compact. 3.24. What is the difference between the highest and the lowest Gross enrolment ratio (%) of Panama?
Ensure brevity in your answer.  6.21. 